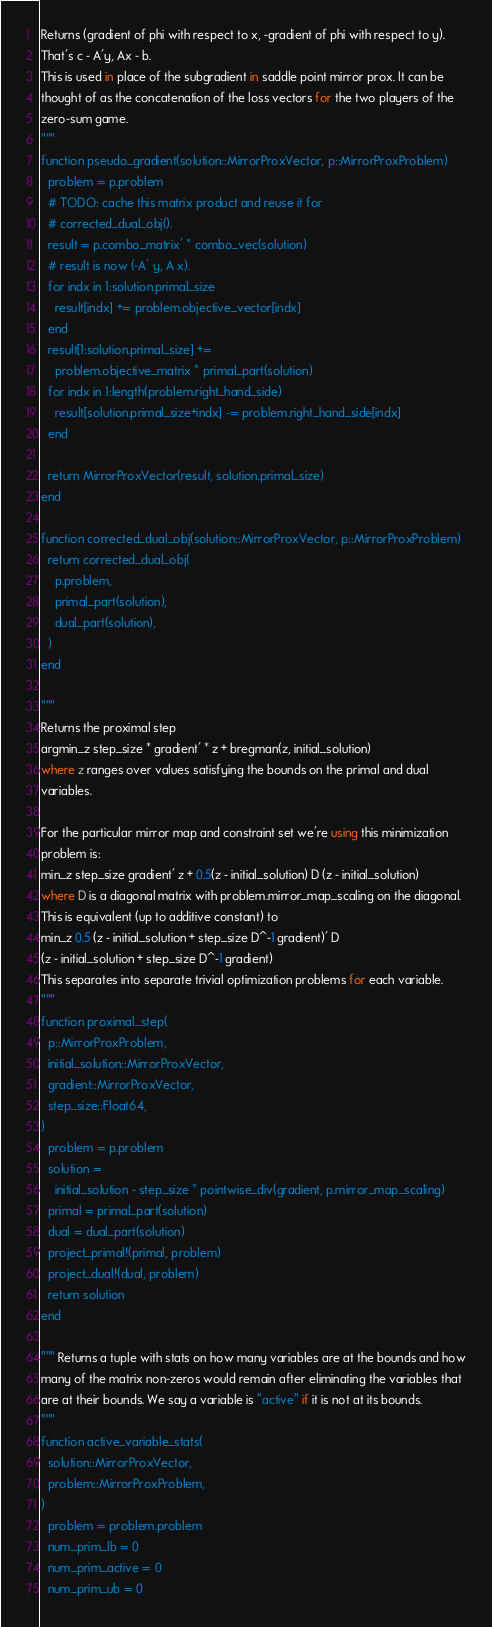Convert code to text. <code><loc_0><loc_0><loc_500><loc_500><_Julia_>Returns (gradient of phi with respect to x, -gradient of phi with respect to y).
That's c - A'y, Ax - b.
This is used in place of the subgradient in saddle point mirror prox. It can be
thought of as the concatenation of the loss vectors for the two players of the
zero-sum game.
"""
function pseudo_gradient(solution::MirrorProxVector, p::MirrorProxProblem)
  problem = p.problem
  # TODO: cache this matrix product and reuse it for
  # corrected_dual_obj().
  result = p.combo_matrix' * combo_vec(solution)
  # result is now (-A' y, A x).
  for indx in 1:solution.primal_size
    result[indx] += problem.objective_vector[indx]
  end
  result[1:solution.primal_size] +=
    problem.objective_matrix * primal_part(solution)
  for indx in 1:length(problem.right_hand_side)
    result[solution.primal_size+indx] -= problem.right_hand_side[indx]
  end

  return MirrorProxVector(result, solution.primal_size)
end

function corrected_dual_obj(solution::MirrorProxVector, p::MirrorProxProblem)
  return corrected_dual_obj(
    p.problem,
    primal_part(solution),
    dual_part(solution),
  )
end

"""
Returns the proximal step
argmin_z step_size * gradient' * z + bregman(z, initial_solution)
where z ranges over values satisfying the bounds on the primal and dual
variables.

For the particular mirror map and constraint set we're using this minimization
problem is:
min_z step_size gradient' z + 0.5(z - initial_solution) D (z - initial_solution)
where D is a diagonal matrix with problem.mirror_map_scaling on the diagonal.
This is equivalent (up to additive constant) to
min_z 0.5 (z - initial_solution + step_size D^-1 gradient)' D
(z - initial_solution + step_size D^-1 gradient)
This separates into separate trivial optimization problems for each variable.
"""
function proximal_step(
  p::MirrorProxProblem,
  initial_solution::MirrorProxVector,
  gradient::MirrorProxVector,
  step_size::Float64,
)
  problem = p.problem
  solution =
    initial_solution - step_size * pointwise_div(gradient, p.mirror_map_scaling)
  primal = primal_part(solution)
  dual = dual_part(solution)
  project_primal!(primal, problem)
  project_dual!(dual, problem)
  return solution
end

""" Returns a tuple with stats on how many variables are at the bounds and how
many of the matrix non-zeros would remain after eliminating the variables that
are at their bounds. We say a variable is "active" if it is not at its bounds.
"""
function active_variable_stats(
  solution::MirrorProxVector,
  problem::MirrorProxProblem,
)
  problem = problem.problem
  num_prim_lb = 0
  num_prim_active = 0
  num_prim_ub = 0</code> 